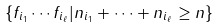<formula> <loc_0><loc_0><loc_500><loc_500>\{ f _ { i _ { 1 } } \cdots f _ { i _ { \ell } } | n _ { i _ { 1 } } + \cdots + n _ { i _ { \ell } } \geq n \}</formula> 